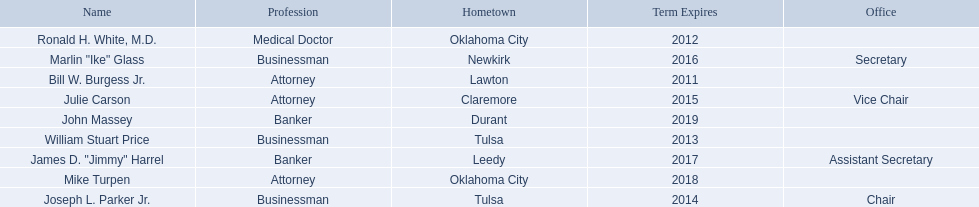What are all the names of oklahoma state regents for higher educations? Bill W. Burgess Jr., Ronald H. White, M.D., William Stuart Price, Joseph L. Parker Jr., Julie Carson, Marlin "Ike" Glass, James D. "Jimmy" Harrel, Mike Turpen, John Massey. Which ones are businessmen? William Stuart Price, Joseph L. Parker Jr., Marlin "Ike" Glass. Of those, who is from tulsa? William Stuart Price, Joseph L. Parker Jr. Whose term expires in 2014? Joseph L. Parker Jr. 